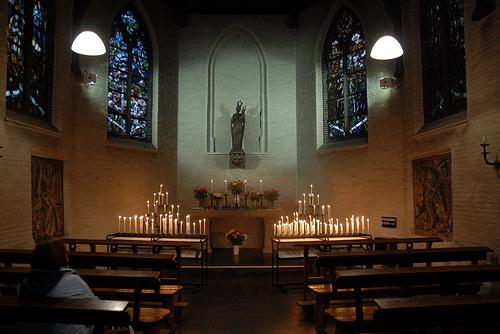Are all the candles lit?
Quick response, please. Yes. Are there windows?
Short answer required. Yes. How many lights are turned on in the photo?
Concise answer only. 2. Is there a gate in this image?
Give a very brief answer. No. How many people are sitting down?
Short answer required. 1. How many people are in the pews?
Give a very brief answer. 1. 